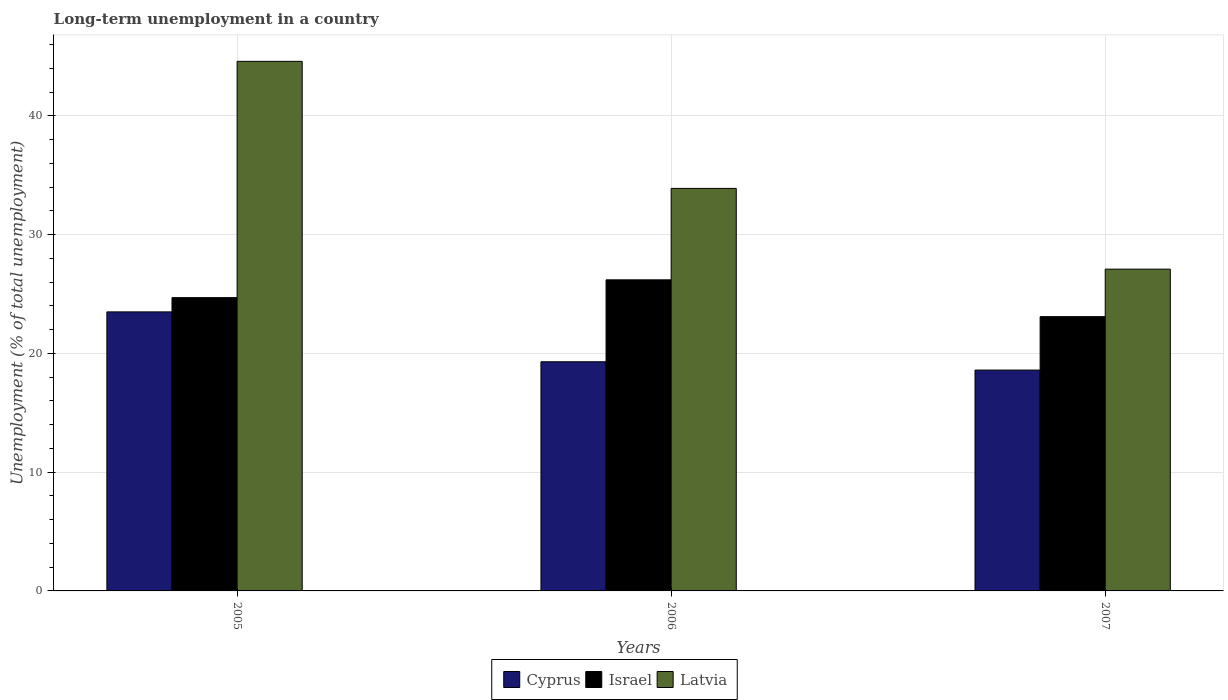How many different coloured bars are there?
Your answer should be compact. 3. How many groups of bars are there?
Provide a short and direct response. 3. Are the number of bars per tick equal to the number of legend labels?
Your response must be concise. Yes. Are the number of bars on each tick of the X-axis equal?
Provide a succinct answer. Yes. How many bars are there on the 2nd tick from the left?
Your response must be concise. 3. How many bars are there on the 2nd tick from the right?
Provide a succinct answer. 3. In how many cases, is the number of bars for a given year not equal to the number of legend labels?
Your answer should be very brief. 0. What is the percentage of long-term unemployed population in Cyprus in 2006?
Provide a short and direct response. 19.3. Across all years, what is the maximum percentage of long-term unemployed population in Latvia?
Give a very brief answer. 44.6. Across all years, what is the minimum percentage of long-term unemployed population in Latvia?
Your answer should be compact. 27.1. What is the total percentage of long-term unemployed population in Latvia in the graph?
Offer a very short reply. 105.6. What is the difference between the percentage of long-term unemployed population in Cyprus in 2006 and that in 2007?
Your answer should be compact. 0.7. What is the difference between the percentage of long-term unemployed population in Latvia in 2007 and the percentage of long-term unemployed population in Cyprus in 2006?
Your answer should be compact. 7.8. What is the average percentage of long-term unemployed population in Latvia per year?
Offer a terse response. 35.2. In the year 2007, what is the difference between the percentage of long-term unemployed population in Cyprus and percentage of long-term unemployed population in Israel?
Keep it short and to the point. -4.5. What is the ratio of the percentage of long-term unemployed population in Cyprus in 2006 to that in 2007?
Keep it short and to the point. 1.04. Is the percentage of long-term unemployed population in Latvia in 2005 less than that in 2006?
Keep it short and to the point. No. Is the difference between the percentage of long-term unemployed population in Cyprus in 2006 and 2007 greater than the difference between the percentage of long-term unemployed population in Israel in 2006 and 2007?
Ensure brevity in your answer.  No. What is the difference between the highest and the second highest percentage of long-term unemployed population in Latvia?
Make the answer very short. 10.7. What is the difference between the highest and the lowest percentage of long-term unemployed population in Cyprus?
Provide a succinct answer. 4.9. In how many years, is the percentage of long-term unemployed population in Israel greater than the average percentage of long-term unemployed population in Israel taken over all years?
Offer a terse response. 2. Is the sum of the percentage of long-term unemployed population in Israel in 2005 and 2007 greater than the maximum percentage of long-term unemployed population in Latvia across all years?
Your response must be concise. Yes. What does the 1st bar from the left in 2007 represents?
Your answer should be compact. Cyprus. What does the 1st bar from the right in 2005 represents?
Give a very brief answer. Latvia. Is it the case that in every year, the sum of the percentage of long-term unemployed population in Israel and percentage of long-term unemployed population in Latvia is greater than the percentage of long-term unemployed population in Cyprus?
Offer a terse response. Yes. How many bars are there?
Make the answer very short. 9. What is the difference between two consecutive major ticks on the Y-axis?
Provide a short and direct response. 10. Does the graph contain any zero values?
Make the answer very short. No. How many legend labels are there?
Offer a very short reply. 3. How are the legend labels stacked?
Offer a terse response. Horizontal. What is the title of the graph?
Keep it short and to the point. Long-term unemployment in a country. Does "Congo (Republic)" appear as one of the legend labels in the graph?
Your response must be concise. No. What is the label or title of the Y-axis?
Keep it short and to the point. Unemployment (% of total unemployment). What is the Unemployment (% of total unemployment) in Cyprus in 2005?
Offer a terse response. 23.5. What is the Unemployment (% of total unemployment) of Israel in 2005?
Your answer should be very brief. 24.7. What is the Unemployment (% of total unemployment) of Latvia in 2005?
Your answer should be compact. 44.6. What is the Unemployment (% of total unemployment) in Cyprus in 2006?
Your response must be concise. 19.3. What is the Unemployment (% of total unemployment) of Israel in 2006?
Your answer should be very brief. 26.2. What is the Unemployment (% of total unemployment) in Latvia in 2006?
Your response must be concise. 33.9. What is the Unemployment (% of total unemployment) in Cyprus in 2007?
Give a very brief answer. 18.6. What is the Unemployment (% of total unemployment) of Israel in 2007?
Keep it short and to the point. 23.1. What is the Unemployment (% of total unemployment) of Latvia in 2007?
Make the answer very short. 27.1. Across all years, what is the maximum Unemployment (% of total unemployment) in Cyprus?
Ensure brevity in your answer.  23.5. Across all years, what is the maximum Unemployment (% of total unemployment) of Israel?
Offer a very short reply. 26.2. Across all years, what is the maximum Unemployment (% of total unemployment) in Latvia?
Provide a succinct answer. 44.6. Across all years, what is the minimum Unemployment (% of total unemployment) of Cyprus?
Your answer should be very brief. 18.6. Across all years, what is the minimum Unemployment (% of total unemployment) of Israel?
Make the answer very short. 23.1. Across all years, what is the minimum Unemployment (% of total unemployment) of Latvia?
Give a very brief answer. 27.1. What is the total Unemployment (% of total unemployment) in Cyprus in the graph?
Your answer should be very brief. 61.4. What is the total Unemployment (% of total unemployment) in Latvia in the graph?
Provide a short and direct response. 105.6. What is the difference between the Unemployment (% of total unemployment) of Cyprus in 2005 and that in 2006?
Make the answer very short. 4.2. What is the difference between the Unemployment (% of total unemployment) in Latvia in 2005 and that in 2006?
Make the answer very short. 10.7. What is the difference between the Unemployment (% of total unemployment) in Israel in 2005 and that in 2007?
Offer a terse response. 1.6. What is the difference between the Unemployment (% of total unemployment) of Cyprus in 2006 and that in 2007?
Provide a succinct answer. 0.7. What is the difference between the Unemployment (% of total unemployment) of Cyprus in 2005 and the Unemployment (% of total unemployment) of Israel in 2006?
Ensure brevity in your answer.  -2.7. What is the difference between the Unemployment (% of total unemployment) in Cyprus in 2006 and the Unemployment (% of total unemployment) in Israel in 2007?
Your answer should be very brief. -3.8. What is the difference between the Unemployment (% of total unemployment) of Cyprus in 2006 and the Unemployment (% of total unemployment) of Latvia in 2007?
Provide a short and direct response. -7.8. What is the average Unemployment (% of total unemployment) in Cyprus per year?
Keep it short and to the point. 20.47. What is the average Unemployment (% of total unemployment) in Israel per year?
Offer a very short reply. 24.67. What is the average Unemployment (% of total unemployment) of Latvia per year?
Offer a terse response. 35.2. In the year 2005, what is the difference between the Unemployment (% of total unemployment) of Cyprus and Unemployment (% of total unemployment) of Latvia?
Your response must be concise. -21.1. In the year 2005, what is the difference between the Unemployment (% of total unemployment) in Israel and Unemployment (% of total unemployment) in Latvia?
Make the answer very short. -19.9. In the year 2006, what is the difference between the Unemployment (% of total unemployment) of Cyprus and Unemployment (% of total unemployment) of Latvia?
Give a very brief answer. -14.6. In the year 2006, what is the difference between the Unemployment (% of total unemployment) in Israel and Unemployment (% of total unemployment) in Latvia?
Your response must be concise. -7.7. In the year 2007, what is the difference between the Unemployment (% of total unemployment) of Cyprus and Unemployment (% of total unemployment) of Latvia?
Your answer should be very brief. -8.5. What is the ratio of the Unemployment (% of total unemployment) in Cyprus in 2005 to that in 2006?
Your answer should be compact. 1.22. What is the ratio of the Unemployment (% of total unemployment) of Israel in 2005 to that in 2006?
Provide a short and direct response. 0.94. What is the ratio of the Unemployment (% of total unemployment) in Latvia in 2005 to that in 2006?
Provide a short and direct response. 1.32. What is the ratio of the Unemployment (% of total unemployment) in Cyprus in 2005 to that in 2007?
Provide a succinct answer. 1.26. What is the ratio of the Unemployment (% of total unemployment) of Israel in 2005 to that in 2007?
Offer a very short reply. 1.07. What is the ratio of the Unemployment (% of total unemployment) in Latvia in 2005 to that in 2007?
Offer a terse response. 1.65. What is the ratio of the Unemployment (% of total unemployment) of Cyprus in 2006 to that in 2007?
Ensure brevity in your answer.  1.04. What is the ratio of the Unemployment (% of total unemployment) of Israel in 2006 to that in 2007?
Make the answer very short. 1.13. What is the ratio of the Unemployment (% of total unemployment) of Latvia in 2006 to that in 2007?
Your answer should be compact. 1.25. What is the difference between the highest and the second highest Unemployment (% of total unemployment) in Cyprus?
Provide a succinct answer. 4.2. What is the difference between the highest and the lowest Unemployment (% of total unemployment) of Cyprus?
Offer a terse response. 4.9. What is the difference between the highest and the lowest Unemployment (% of total unemployment) of Latvia?
Keep it short and to the point. 17.5. 